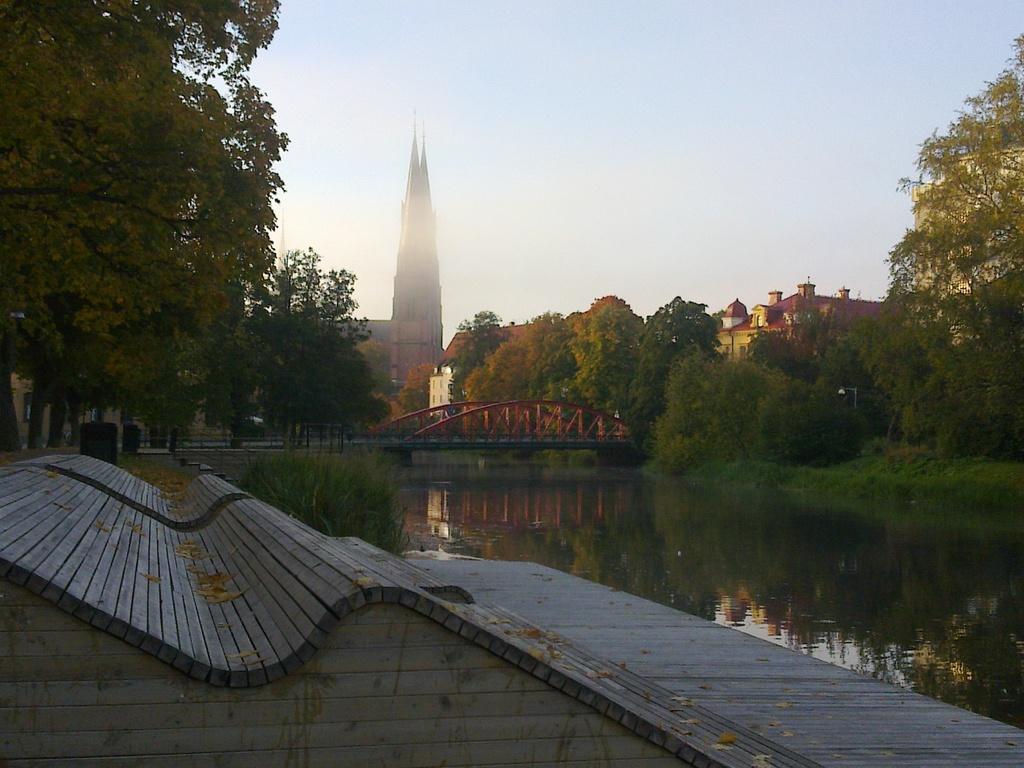Describe this image in one or two sentences. In this image we can see a bridge, water, some plants, grass, a group of trees, a tower, some buildings and the sky. On the bottom of the image we can see some dried leaves on the ground. 